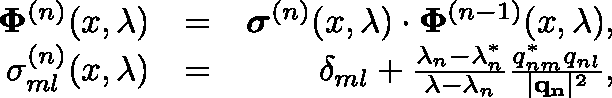Convert formula to latex. <formula><loc_0><loc_0><loc_500><loc_500>\begin{array} { r l r } { \Phi ^ { ( n ) } ( x , \lambda ) } & { = } & { \sigma ^ { ( n ) } ( x , \lambda ) \cdot \Phi ^ { ( n - 1 ) } ( x , \lambda ) , } \\ { \sigma _ { m l } ^ { ( n ) } ( x , \lambda ) } & { = } & { \delta _ { m l } + \frac { \lambda _ { n } - \lambda _ { n } ^ { * } } { \lambda - \lambda _ { n } } \frac { q _ { n m } ^ { * } q _ { n l } } { | q _ { n } | ^ { 2 } } , } \end{array}</formula> 